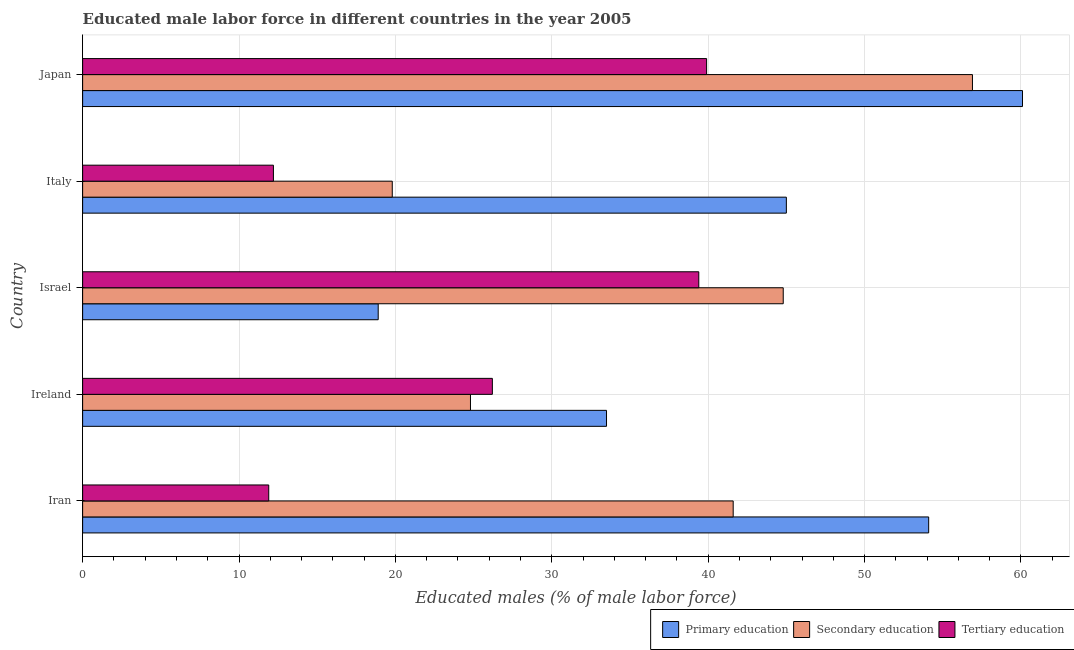How many groups of bars are there?
Offer a very short reply. 5. Are the number of bars per tick equal to the number of legend labels?
Keep it short and to the point. Yes. How many bars are there on the 4th tick from the top?
Provide a short and direct response. 3. How many bars are there on the 4th tick from the bottom?
Offer a very short reply. 3. In how many cases, is the number of bars for a given country not equal to the number of legend labels?
Ensure brevity in your answer.  0. What is the percentage of male labor force who received tertiary education in Ireland?
Provide a short and direct response. 26.2. Across all countries, what is the maximum percentage of male labor force who received primary education?
Ensure brevity in your answer.  60.1. Across all countries, what is the minimum percentage of male labor force who received tertiary education?
Give a very brief answer. 11.9. What is the total percentage of male labor force who received tertiary education in the graph?
Your response must be concise. 129.6. What is the difference between the percentage of male labor force who received secondary education in Israel and the percentage of male labor force who received primary education in Italy?
Give a very brief answer. -0.2. What is the average percentage of male labor force who received secondary education per country?
Keep it short and to the point. 37.58. What is the difference between the percentage of male labor force who received tertiary education and percentage of male labor force who received secondary education in Israel?
Provide a succinct answer. -5.4. In how many countries, is the percentage of male labor force who received primary education greater than 20 %?
Make the answer very short. 4. What is the ratio of the percentage of male labor force who received primary education in Ireland to that in Japan?
Make the answer very short. 0.56. Is the percentage of male labor force who received secondary education in Ireland less than that in Israel?
Ensure brevity in your answer.  Yes. What is the difference between the highest and the second highest percentage of male labor force who received secondary education?
Offer a very short reply. 12.1. Is the sum of the percentage of male labor force who received primary education in Iran and Japan greater than the maximum percentage of male labor force who received tertiary education across all countries?
Offer a very short reply. Yes. What does the 2nd bar from the bottom in Ireland represents?
Ensure brevity in your answer.  Secondary education. How many bars are there?
Your answer should be very brief. 15. How many countries are there in the graph?
Provide a succinct answer. 5. What is the difference between two consecutive major ticks on the X-axis?
Provide a succinct answer. 10. Are the values on the major ticks of X-axis written in scientific E-notation?
Your response must be concise. No. What is the title of the graph?
Your response must be concise. Educated male labor force in different countries in the year 2005. Does "Interest" appear as one of the legend labels in the graph?
Ensure brevity in your answer.  No. What is the label or title of the X-axis?
Keep it short and to the point. Educated males (% of male labor force). What is the label or title of the Y-axis?
Provide a short and direct response. Country. What is the Educated males (% of male labor force) in Primary education in Iran?
Your response must be concise. 54.1. What is the Educated males (% of male labor force) in Secondary education in Iran?
Your response must be concise. 41.6. What is the Educated males (% of male labor force) of Tertiary education in Iran?
Keep it short and to the point. 11.9. What is the Educated males (% of male labor force) of Primary education in Ireland?
Offer a terse response. 33.5. What is the Educated males (% of male labor force) of Secondary education in Ireland?
Make the answer very short. 24.8. What is the Educated males (% of male labor force) of Tertiary education in Ireland?
Your answer should be compact. 26.2. What is the Educated males (% of male labor force) of Primary education in Israel?
Your response must be concise. 18.9. What is the Educated males (% of male labor force) in Secondary education in Israel?
Provide a short and direct response. 44.8. What is the Educated males (% of male labor force) in Tertiary education in Israel?
Your answer should be compact. 39.4. What is the Educated males (% of male labor force) in Primary education in Italy?
Provide a short and direct response. 45. What is the Educated males (% of male labor force) of Secondary education in Italy?
Offer a very short reply. 19.8. What is the Educated males (% of male labor force) of Tertiary education in Italy?
Offer a terse response. 12.2. What is the Educated males (% of male labor force) in Primary education in Japan?
Offer a very short reply. 60.1. What is the Educated males (% of male labor force) in Secondary education in Japan?
Your answer should be compact. 56.9. What is the Educated males (% of male labor force) in Tertiary education in Japan?
Offer a terse response. 39.9. Across all countries, what is the maximum Educated males (% of male labor force) in Primary education?
Provide a succinct answer. 60.1. Across all countries, what is the maximum Educated males (% of male labor force) in Secondary education?
Provide a short and direct response. 56.9. Across all countries, what is the maximum Educated males (% of male labor force) of Tertiary education?
Your answer should be very brief. 39.9. Across all countries, what is the minimum Educated males (% of male labor force) of Primary education?
Provide a short and direct response. 18.9. Across all countries, what is the minimum Educated males (% of male labor force) of Secondary education?
Ensure brevity in your answer.  19.8. Across all countries, what is the minimum Educated males (% of male labor force) in Tertiary education?
Ensure brevity in your answer.  11.9. What is the total Educated males (% of male labor force) in Primary education in the graph?
Offer a very short reply. 211.6. What is the total Educated males (% of male labor force) in Secondary education in the graph?
Your answer should be compact. 187.9. What is the total Educated males (% of male labor force) in Tertiary education in the graph?
Your response must be concise. 129.6. What is the difference between the Educated males (% of male labor force) of Primary education in Iran and that in Ireland?
Your response must be concise. 20.6. What is the difference between the Educated males (% of male labor force) in Secondary education in Iran and that in Ireland?
Ensure brevity in your answer.  16.8. What is the difference between the Educated males (% of male labor force) in Tertiary education in Iran and that in Ireland?
Keep it short and to the point. -14.3. What is the difference between the Educated males (% of male labor force) of Primary education in Iran and that in Israel?
Give a very brief answer. 35.2. What is the difference between the Educated males (% of male labor force) of Secondary education in Iran and that in Israel?
Offer a very short reply. -3.2. What is the difference between the Educated males (% of male labor force) of Tertiary education in Iran and that in Israel?
Make the answer very short. -27.5. What is the difference between the Educated males (% of male labor force) of Primary education in Iran and that in Italy?
Offer a terse response. 9.1. What is the difference between the Educated males (% of male labor force) of Secondary education in Iran and that in Italy?
Provide a short and direct response. 21.8. What is the difference between the Educated males (% of male labor force) of Secondary education in Iran and that in Japan?
Your answer should be compact. -15.3. What is the difference between the Educated males (% of male labor force) in Tertiary education in Ireland and that in Italy?
Offer a very short reply. 14. What is the difference between the Educated males (% of male labor force) in Primary education in Ireland and that in Japan?
Your answer should be compact. -26.6. What is the difference between the Educated males (% of male labor force) in Secondary education in Ireland and that in Japan?
Provide a short and direct response. -32.1. What is the difference between the Educated males (% of male labor force) of Tertiary education in Ireland and that in Japan?
Your answer should be compact. -13.7. What is the difference between the Educated males (% of male labor force) in Primary education in Israel and that in Italy?
Offer a very short reply. -26.1. What is the difference between the Educated males (% of male labor force) of Secondary education in Israel and that in Italy?
Ensure brevity in your answer.  25. What is the difference between the Educated males (% of male labor force) of Tertiary education in Israel and that in Italy?
Ensure brevity in your answer.  27.2. What is the difference between the Educated males (% of male labor force) in Primary education in Israel and that in Japan?
Offer a terse response. -41.2. What is the difference between the Educated males (% of male labor force) of Secondary education in Israel and that in Japan?
Provide a short and direct response. -12.1. What is the difference between the Educated males (% of male labor force) in Tertiary education in Israel and that in Japan?
Make the answer very short. -0.5. What is the difference between the Educated males (% of male labor force) of Primary education in Italy and that in Japan?
Make the answer very short. -15.1. What is the difference between the Educated males (% of male labor force) of Secondary education in Italy and that in Japan?
Ensure brevity in your answer.  -37.1. What is the difference between the Educated males (% of male labor force) of Tertiary education in Italy and that in Japan?
Your answer should be compact. -27.7. What is the difference between the Educated males (% of male labor force) of Primary education in Iran and the Educated males (% of male labor force) of Secondary education in Ireland?
Your response must be concise. 29.3. What is the difference between the Educated males (% of male labor force) of Primary education in Iran and the Educated males (% of male labor force) of Tertiary education in Ireland?
Provide a succinct answer. 27.9. What is the difference between the Educated males (% of male labor force) in Secondary education in Iran and the Educated males (% of male labor force) in Tertiary education in Israel?
Provide a short and direct response. 2.2. What is the difference between the Educated males (% of male labor force) in Primary education in Iran and the Educated males (% of male labor force) in Secondary education in Italy?
Provide a short and direct response. 34.3. What is the difference between the Educated males (% of male labor force) in Primary education in Iran and the Educated males (% of male labor force) in Tertiary education in Italy?
Provide a succinct answer. 41.9. What is the difference between the Educated males (% of male labor force) of Secondary education in Iran and the Educated males (% of male labor force) of Tertiary education in Italy?
Your answer should be compact. 29.4. What is the difference between the Educated males (% of male labor force) in Primary education in Ireland and the Educated males (% of male labor force) in Secondary education in Israel?
Give a very brief answer. -11.3. What is the difference between the Educated males (% of male labor force) of Secondary education in Ireland and the Educated males (% of male labor force) of Tertiary education in Israel?
Offer a very short reply. -14.6. What is the difference between the Educated males (% of male labor force) of Primary education in Ireland and the Educated males (% of male labor force) of Tertiary education in Italy?
Keep it short and to the point. 21.3. What is the difference between the Educated males (% of male labor force) in Secondary education in Ireland and the Educated males (% of male labor force) in Tertiary education in Italy?
Your answer should be compact. 12.6. What is the difference between the Educated males (% of male labor force) in Primary education in Ireland and the Educated males (% of male labor force) in Secondary education in Japan?
Provide a short and direct response. -23.4. What is the difference between the Educated males (% of male labor force) in Secondary education in Ireland and the Educated males (% of male labor force) in Tertiary education in Japan?
Give a very brief answer. -15.1. What is the difference between the Educated males (% of male labor force) in Primary education in Israel and the Educated males (% of male labor force) in Secondary education in Italy?
Provide a short and direct response. -0.9. What is the difference between the Educated males (% of male labor force) of Primary education in Israel and the Educated males (% of male labor force) of Tertiary education in Italy?
Keep it short and to the point. 6.7. What is the difference between the Educated males (% of male labor force) in Secondary education in Israel and the Educated males (% of male labor force) in Tertiary education in Italy?
Your response must be concise. 32.6. What is the difference between the Educated males (% of male labor force) of Primary education in Israel and the Educated males (% of male labor force) of Secondary education in Japan?
Your answer should be compact. -38. What is the difference between the Educated males (% of male labor force) of Primary education in Israel and the Educated males (% of male labor force) of Tertiary education in Japan?
Make the answer very short. -21. What is the difference between the Educated males (% of male labor force) in Primary education in Italy and the Educated males (% of male labor force) in Tertiary education in Japan?
Provide a short and direct response. 5.1. What is the difference between the Educated males (% of male labor force) in Secondary education in Italy and the Educated males (% of male labor force) in Tertiary education in Japan?
Offer a terse response. -20.1. What is the average Educated males (% of male labor force) in Primary education per country?
Provide a succinct answer. 42.32. What is the average Educated males (% of male labor force) of Secondary education per country?
Offer a very short reply. 37.58. What is the average Educated males (% of male labor force) of Tertiary education per country?
Provide a short and direct response. 25.92. What is the difference between the Educated males (% of male labor force) of Primary education and Educated males (% of male labor force) of Secondary education in Iran?
Your answer should be compact. 12.5. What is the difference between the Educated males (% of male labor force) of Primary education and Educated males (% of male labor force) of Tertiary education in Iran?
Give a very brief answer. 42.2. What is the difference between the Educated males (% of male labor force) in Secondary education and Educated males (% of male labor force) in Tertiary education in Iran?
Provide a short and direct response. 29.7. What is the difference between the Educated males (% of male labor force) in Secondary education and Educated males (% of male labor force) in Tertiary education in Ireland?
Offer a terse response. -1.4. What is the difference between the Educated males (% of male labor force) of Primary education and Educated males (% of male labor force) of Secondary education in Israel?
Make the answer very short. -25.9. What is the difference between the Educated males (% of male labor force) of Primary education and Educated males (% of male labor force) of Tertiary education in Israel?
Ensure brevity in your answer.  -20.5. What is the difference between the Educated males (% of male labor force) in Primary education and Educated males (% of male labor force) in Secondary education in Italy?
Keep it short and to the point. 25.2. What is the difference between the Educated males (% of male labor force) in Primary education and Educated males (% of male labor force) in Tertiary education in Italy?
Make the answer very short. 32.8. What is the difference between the Educated males (% of male labor force) in Primary education and Educated males (% of male labor force) in Tertiary education in Japan?
Provide a succinct answer. 20.2. What is the difference between the Educated males (% of male labor force) of Secondary education and Educated males (% of male labor force) of Tertiary education in Japan?
Your response must be concise. 17. What is the ratio of the Educated males (% of male labor force) in Primary education in Iran to that in Ireland?
Your response must be concise. 1.61. What is the ratio of the Educated males (% of male labor force) of Secondary education in Iran to that in Ireland?
Your response must be concise. 1.68. What is the ratio of the Educated males (% of male labor force) in Tertiary education in Iran to that in Ireland?
Make the answer very short. 0.45. What is the ratio of the Educated males (% of male labor force) of Primary education in Iran to that in Israel?
Provide a succinct answer. 2.86. What is the ratio of the Educated males (% of male labor force) in Tertiary education in Iran to that in Israel?
Provide a succinct answer. 0.3. What is the ratio of the Educated males (% of male labor force) in Primary education in Iran to that in Italy?
Ensure brevity in your answer.  1.2. What is the ratio of the Educated males (% of male labor force) of Secondary education in Iran to that in Italy?
Offer a terse response. 2.1. What is the ratio of the Educated males (% of male labor force) in Tertiary education in Iran to that in Italy?
Make the answer very short. 0.98. What is the ratio of the Educated males (% of male labor force) of Primary education in Iran to that in Japan?
Offer a very short reply. 0.9. What is the ratio of the Educated males (% of male labor force) in Secondary education in Iran to that in Japan?
Ensure brevity in your answer.  0.73. What is the ratio of the Educated males (% of male labor force) in Tertiary education in Iran to that in Japan?
Offer a very short reply. 0.3. What is the ratio of the Educated males (% of male labor force) of Primary education in Ireland to that in Israel?
Ensure brevity in your answer.  1.77. What is the ratio of the Educated males (% of male labor force) of Secondary education in Ireland to that in Israel?
Provide a short and direct response. 0.55. What is the ratio of the Educated males (% of male labor force) in Tertiary education in Ireland to that in Israel?
Offer a very short reply. 0.67. What is the ratio of the Educated males (% of male labor force) in Primary education in Ireland to that in Italy?
Give a very brief answer. 0.74. What is the ratio of the Educated males (% of male labor force) in Secondary education in Ireland to that in Italy?
Provide a short and direct response. 1.25. What is the ratio of the Educated males (% of male labor force) of Tertiary education in Ireland to that in Italy?
Make the answer very short. 2.15. What is the ratio of the Educated males (% of male labor force) in Primary education in Ireland to that in Japan?
Provide a succinct answer. 0.56. What is the ratio of the Educated males (% of male labor force) of Secondary education in Ireland to that in Japan?
Provide a short and direct response. 0.44. What is the ratio of the Educated males (% of male labor force) in Tertiary education in Ireland to that in Japan?
Your answer should be very brief. 0.66. What is the ratio of the Educated males (% of male labor force) of Primary education in Israel to that in Italy?
Ensure brevity in your answer.  0.42. What is the ratio of the Educated males (% of male labor force) in Secondary education in Israel to that in Italy?
Your answer should be very brief. 2.26. What is the ratio of the Educated males (% of male labor force) in Tertiary education in Israel to that in Italy?
Keep it short and to the point. 3.23. What is the ratio of the Educated males (% of male labor force) in Primary education in Israel to that in Japan?
Ensure brevity in your answer.  0.31. What is the ratio of the Educated males (% of male labor force) in Secondary education in Israel to that in Japan?
Provide a short and direct response. 0.79. What is the ratio of the Educated males (% of male labor force) in Tertiary education in Israel to that in Japan?
Your answer should be compact. 0.99. What is the ratio of the Educated males (% of male labor force) in Primary education in Italy to that in Japan?
Your answer should be compact. 0.75. What is the ratio of the Educated males (% of male labor force) of Secondary education in Italy to that in Japan?
Ensure brevity in your answer.  0.35. What is the ratio of the Educated males (% of male labor force) of Tertiary education in Italy to that in Japan?
Your answer should be compact. 0.31. What is the difference between the highest and the second highest Educated males (% of male labor force) in Tertiary education?
Your answer should be compact. 0.5. What is the difference between the highest and the lowest Educated males (% of male labor force) of Primary education?
Keep it short and to the point. 41.2. What is the difference between the highest and the lowest Educated males (% of male labor force) in Secondary education?
Keep it short and to the point. 37.1. 